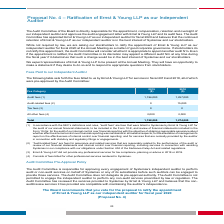From Systemax's financial document, What are the audit fees incurred by the company in 2018 and 2019? The document shows two values: 1,257,000 and 1,196,000. From the document: "Audit fees (1) 1,196,000 1,257,000 Audit fees (1) 1,196,000 1,257,000..." Also, What does "all other fee" refer to? fees billed for other professional services rendered to Systemax.. The document states: "(4) Consists of fees billed for other professional services rendered to Systemax...." Also, What are the all other fees incurred by the company in 2018 and 2019? The document shows two values: 2,000 and 2,000. From the document: "All other fees (4) 2,000 2,000..." Also, can you calculate: What is the percentage change in all other fees incurred by the company between 2018 and 2019? I cannot find a specific answer to this question in the financial document. Also, can you calculate: What is the value of the audit-related fees as a percentage of the total fees paid to the auditor in 2018? Based on the calculation: 15,000/1,274,000 , the result is 1.18 (percentage). This is based on the information: "Audit-related fees (2) 0 15,000 Total 1,198,000 1,274,000..." The key data points involved are: 1,274,000, 15,000. Also, can you calculate: What is the change in audit fees between 2018 and 2019? Based on the calculation: 1,257,000 - 1,196,000 , the result is 61000. This is based on the information: "Audit fees (1) 1,196,000 1,257,000 Audit fees (1) 1,196,000 1,257,000..." The key data points involved are: 1,196,000, 1,257,000. 